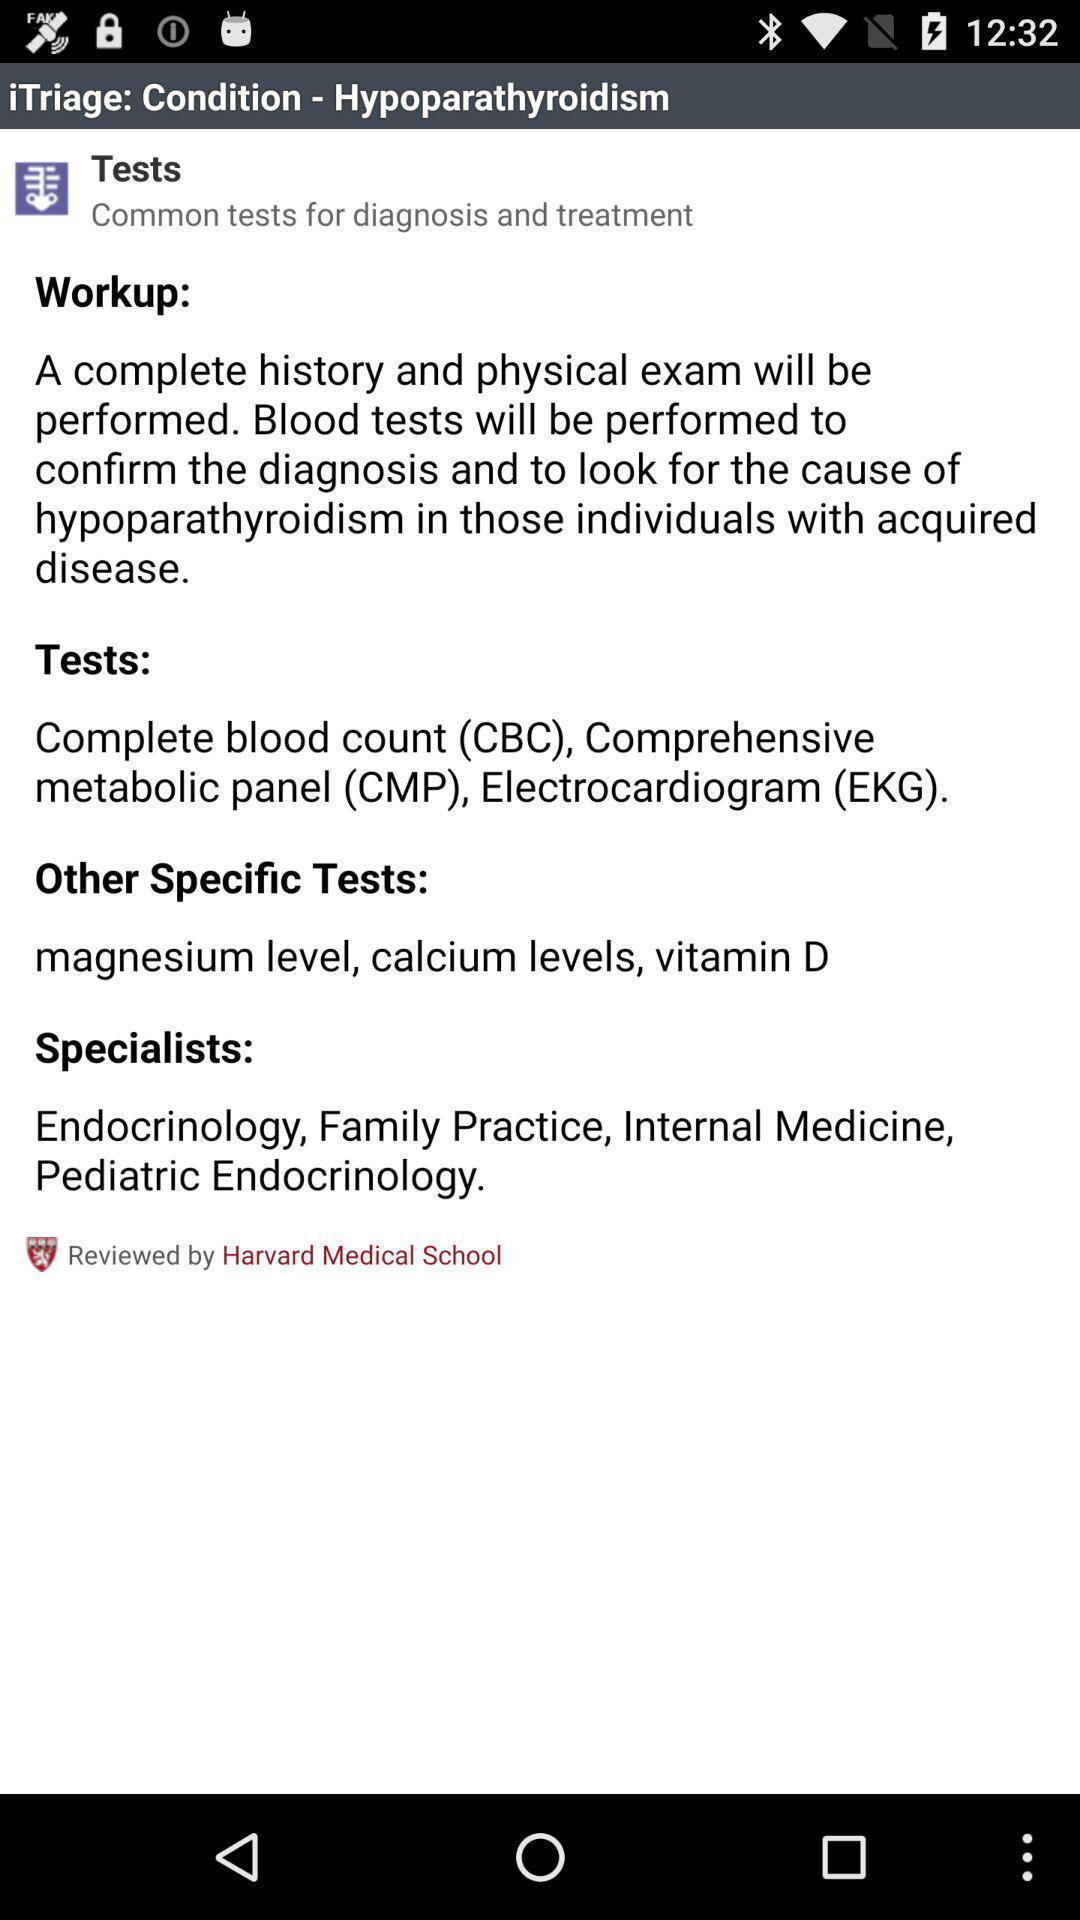What is the overall content of this screenshot? Page with diagnosis and treatment details. 